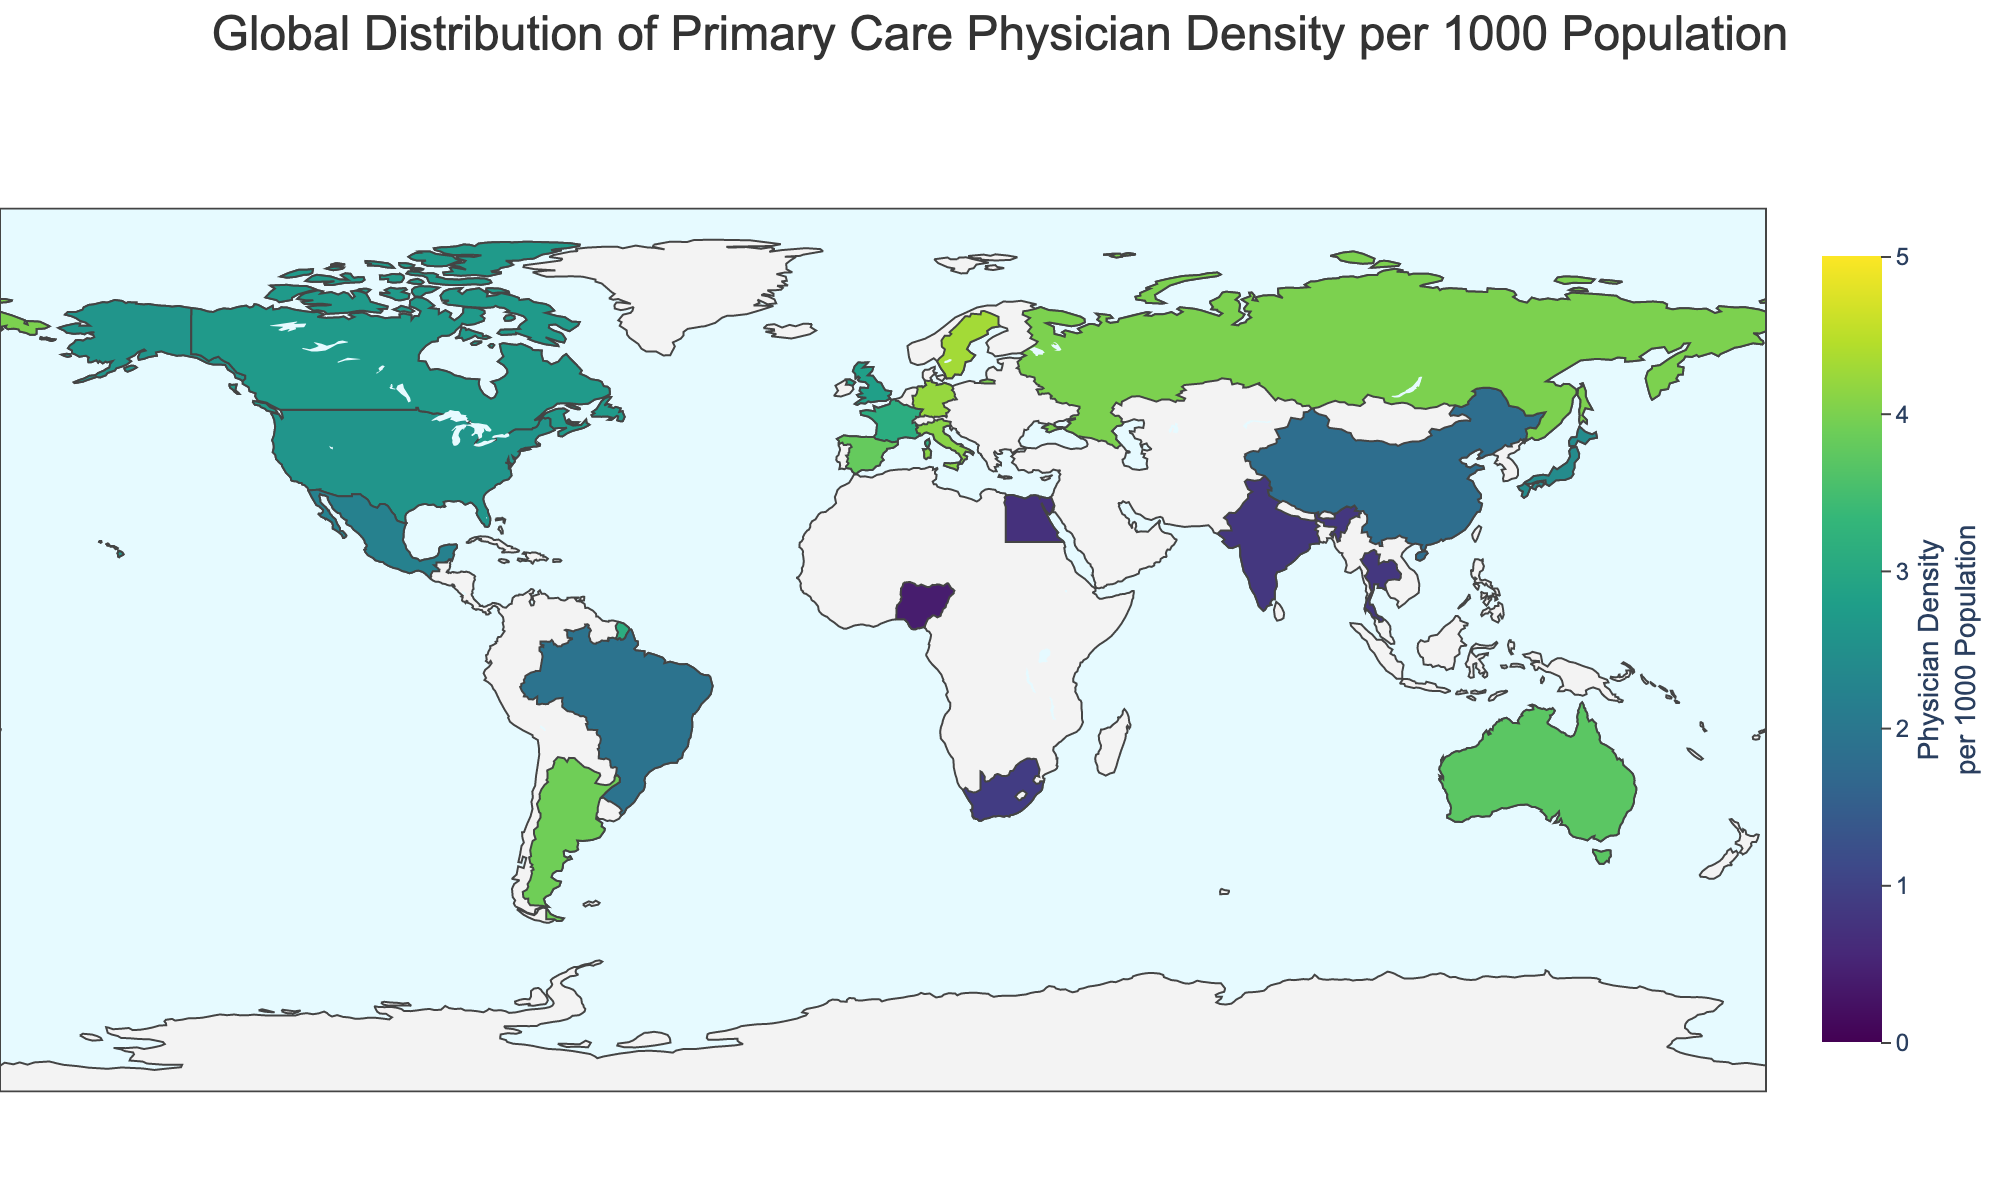What's the title of the figure? The title of the figure is displayed at the top and it provides a brief description of what the figure represents.
Answer: Global Distribution of Primary Care Physician Density per 1000 Population Which country has the highest density of primary care physicians? By examining the color scale, the darkest color indicates the highest density. The country with the highest density of primary care physicians is Sweden.
Answer: Sweden Which country has a primary care physician density of 2.6 per 1000 population? By hovering over the different countries or referring to the data legend, we can find that the United States has a primary care physician density of 2.6.
Answer: United States What's the average physician density among the listed countries? To find the average, sum all the densities and divide by the number of countries. The total density is 54.4 (2.6 + 2.8 + 2.7 + 3.7 + 4.2 + 3.1 + 2.4 + 1.9 + 0.8 + 0.9 + 1.8 + 4.0 + 4.3 + 2.2 + 0.7 + 0.4 + 0.8 + 3.9 + 4.1 + 3.8) and there are 20 countries. Average = 54.4 / 20.
Answer: 2.72 Compare the physician density between Canada and Japan. Which country has a higher density? By looking at the data, Canada has a density of 2.7 and Japan has 2.4. Therefore, Canada has a higher physician density compared to Japan.
Answer: Canada How does the primary care physician density in South Africa compare to Brazil? South Africa has a density of 0.9, while Brazil has 1.9. Brazil has a higher primary care physician density than South Africa.
Answer: Brazil What is the range of physician densities depicted on the color scale? The color scale starts at 0 and goes up to 5, as indicated by the color bar on the side of the figure.
Answer: 0 to 5 Identify two countries with the lowest primary care physician density. The two countries with the lightest colors (indicating the lowest densities) are Nigeria and Egypt with densities of 0.4 and 0.7 respectively.
Answer: Nigeria and Egypt What is the physician density of Germany? Hovering over Germany or checking the data list shows that Germany has a physician density of 4.2
Answer: 4.2 Which countries have a physician density that is above the global average? The global average, as previously calculated, is 2.72. The countries with a density above this average are Australia (3.7), Germany (4.2), France (3.1), Russia (4.0), Sweden (4.3), Argentina (3.9), Italy (4.1), and Spain (3.8).
Answer: Australia, Germany, France, Russia, Sweden, Argentina, Italy, Spain 